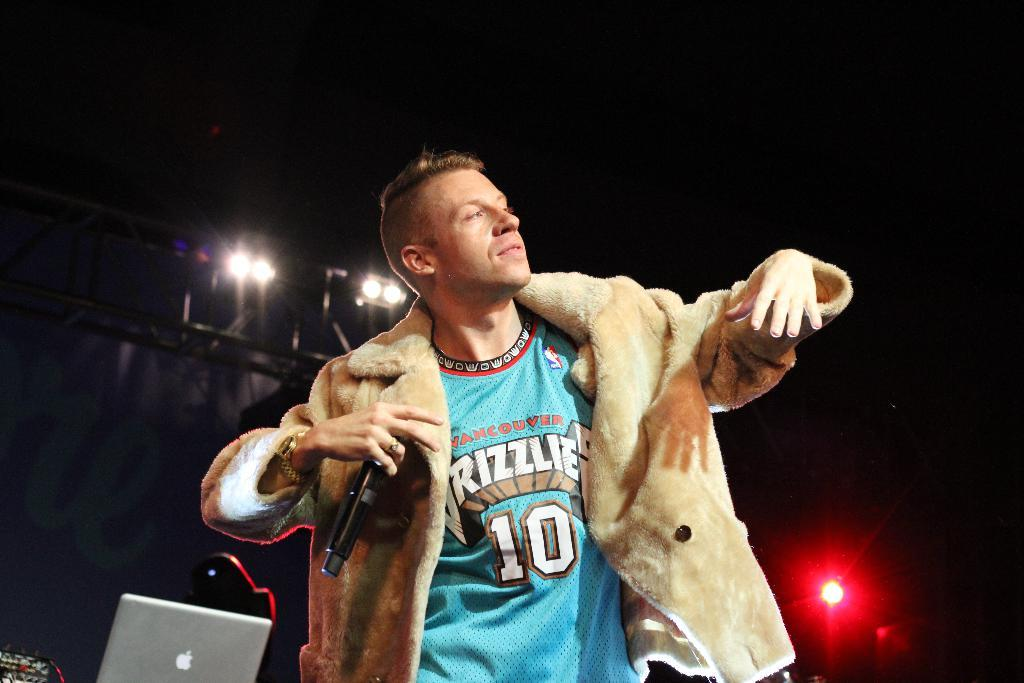Who is present in the image? There is a man in the image. What is the man doing in the image? The man is standing in the image. What is the man holding in the image? The man is holding a microphone in the image. What type of clothing is the man wearing in the image? The man is wearing a jacket and a T-shirt in the image. What can be seen in the background of the image? There are lights visible in the background of the image. What type of bird is perched on the man's shoulder in the image? There is no bird present in the image; the man is holding a microphone and standing. 